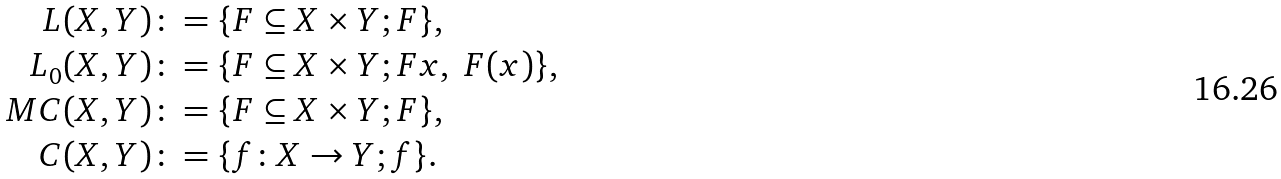<formula> <loc_0><loc_0><loc_500><loc_500>L ( X , Y ) & \colon = \{ F \subseteq X \times Y ; F \} , \\ L _ { 0 } ( X , Y ) & \colon = \{ F \subseteq X \times Y ; F x , \ F ( x ) \} , \\ M C ( X , Y ) & \colon = \{ F \subseteq X \times Y ; F \} , \\ C ( X , Y ) & \colon = \{ f \colon X \to Y ; f \} .</formula> 